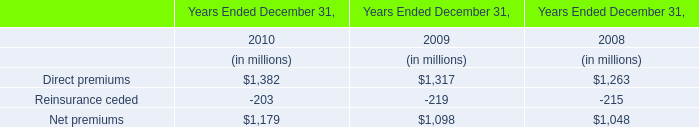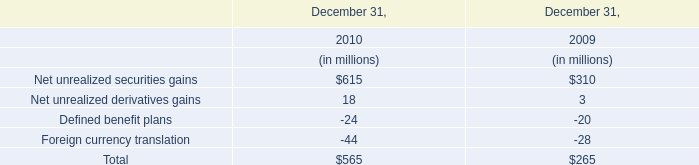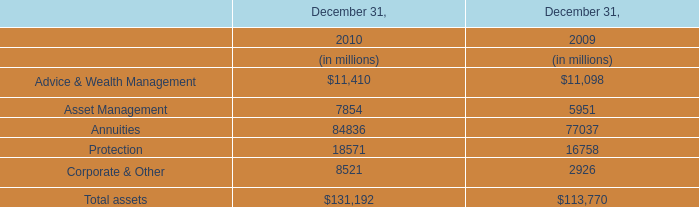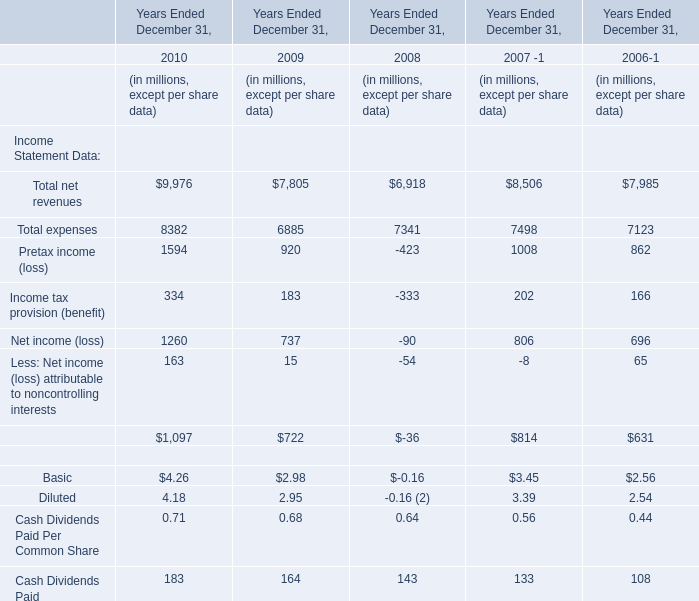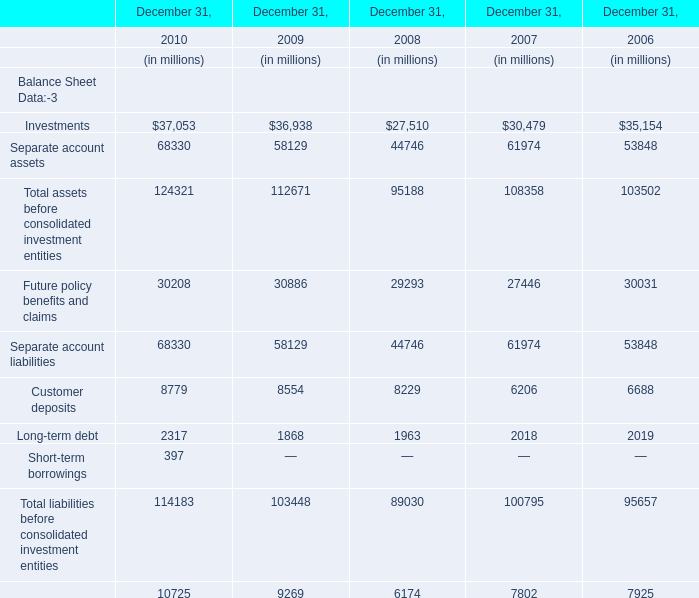what percent of the total share-based compensation expense in 2016 was related to stock options? 
Computations: (7 / 36)
Answer: 0.19444. 